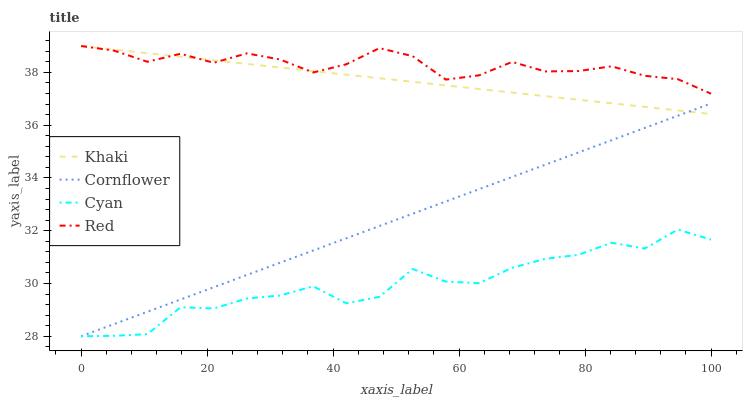Does Cyan have the minimum area under the curve?
Answer yes or no. Yes. Does Red have the maximum area under the curve?
Answer yes or no. Yes. Does Khaki have the minimum area under the curve?
Answer yes or no. No. Does Khaki have the maximum area under the curve?
Answer yes or no. No. Is Cornflower the smoothest?
Answer yes or no. Yes. Is Cyan the roughest?
Answer yes or no. Yes. Is Khaki the smoothest?
Answer yes or no. No. Is Khaki the roughest?
Answer yes or no. No. Does Cornflower have the lowest value?
Answer yes or no. Yes. Does Khaki have the lowest value?
Answer yes or no. No. Does Red have the highest value?
Answer yes or no. Yes. Does Cyan have the highest value?
Answer yes or no. No. Is Cyan less than Red?
Answer yes or no. Yes. Is Red greater than Cornflower?
Answer yes or no. Yes. Does Khaki intersect Red?
Answer yes or no. Yes. Is Khaki less than Red?
Answer yes or no. No. Is Khaki greater than Red?
Answer yes or no. No. Does Cyan intersect Red?
Answer yes or no. No. 